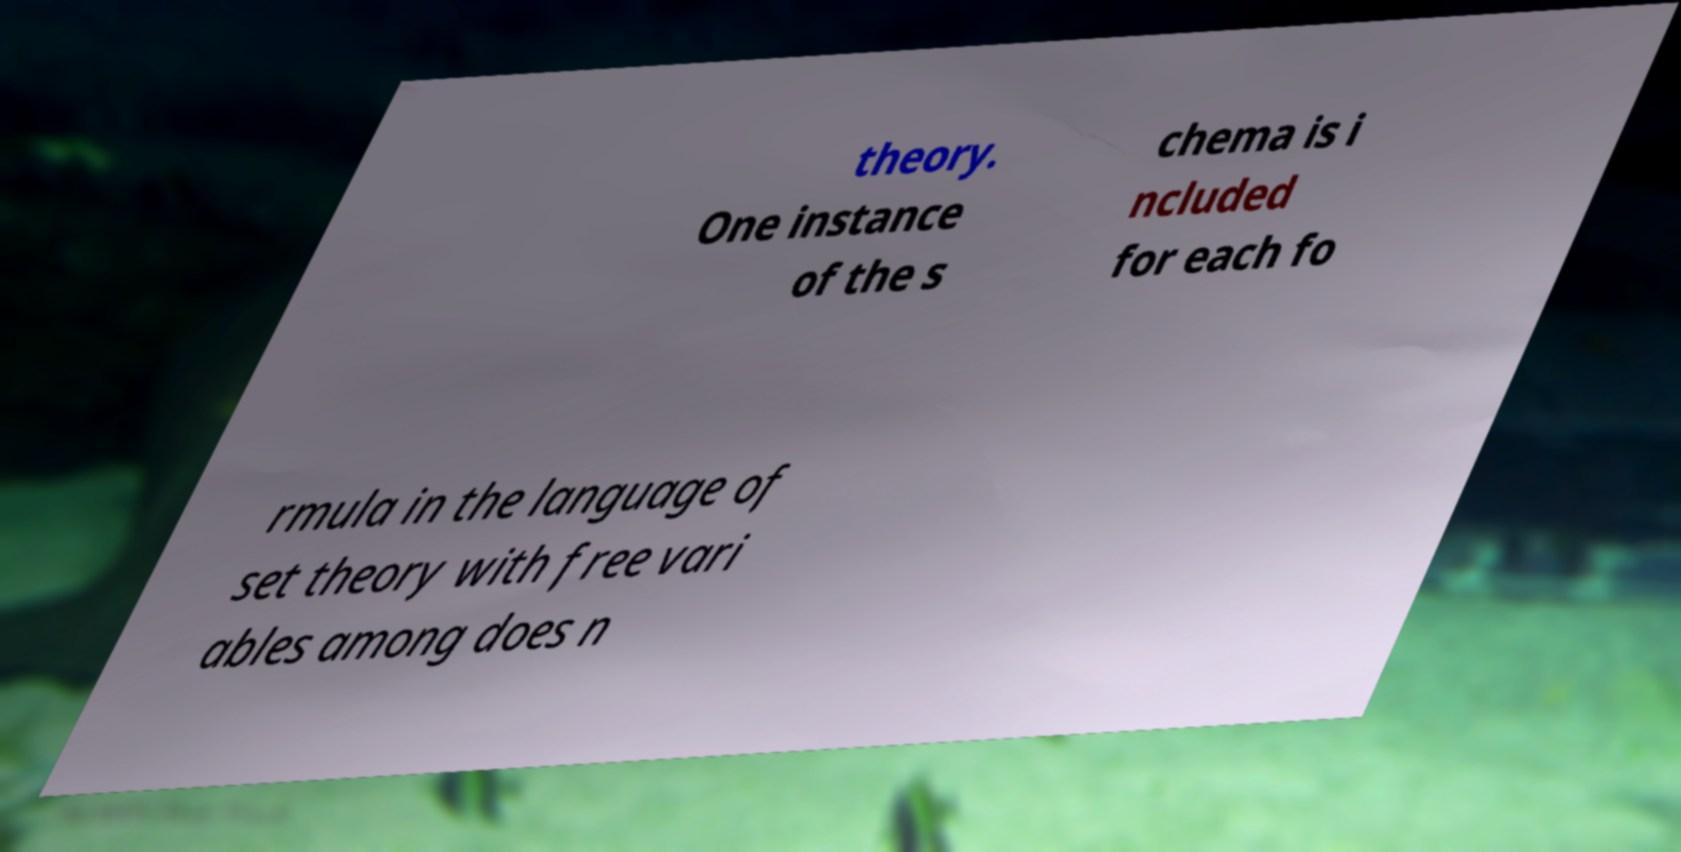Can you accurately transcribe the text from the provided image for me? theory. One instance of the s chema is i ncluded for each fo rmula in the language of set theory with free vari ables among does n 